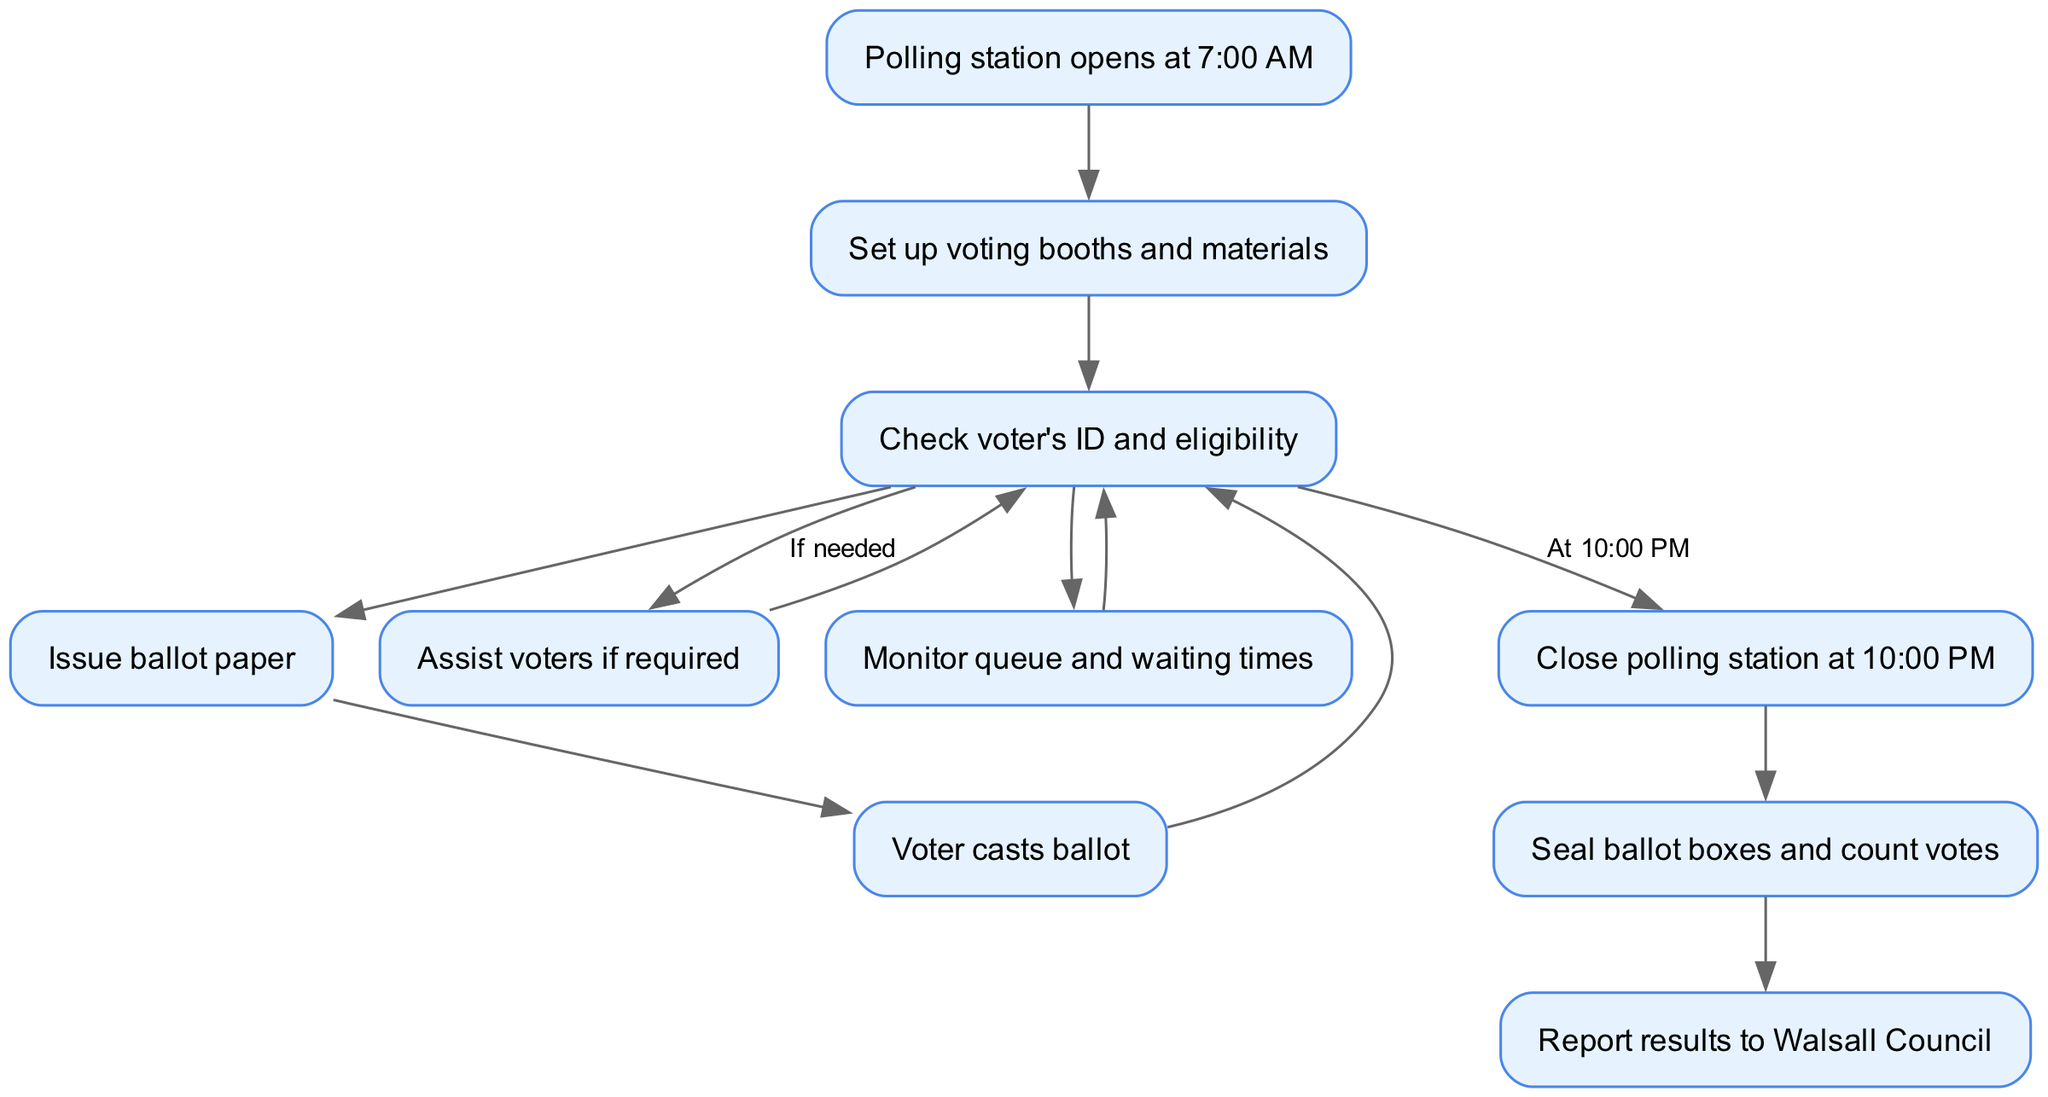What time does the polling station open? The diagram indicates that the polling station opens at 7:00 AM at the starting node.
Answer: 7:00 AM What is the last activity before closing the polling station? The last activity before closing the polling station is to seal ballot boxes and count votes, as shown in the flow following the close node.
Answer: Seal ballot boxes and count votes How many main procedural steps are there before closing the polling station? To answer this, we follow the connections from the setup node through to the check, assist, monitor, and closing, which sums up to six main procedural steps before closing.
Answer: Six What happens to the voter after casting a ballot? The diagram shows that after a voter casts a ballot, they return to the check node, indicating that further steps may occur based on the election procedure.
Answer: Return to check What assistance is provided to voters? If needed, assistance can be provided to voters, as indicated by the connection from the check node to the assist node labeled "If needed."
Answer: Assist voters if required What is issued to voters after checking their ID? After checking a voter's ID and eligibility, the next step is to issue a ballot paper, as shown by the connection from the check node to the issue node.
Answer: Issue ballot paper How do polling station staff monitor the voting process? Staff monitor the voting process by monitoring the queue and waiting times, as indicated by the flow from the check node to the monitor node.
Answer: Monitor queue and waiting times What is reported at the end of the election day procedures? At the end of the election day procedures, results are reported to Walsall Council, as shown in the final step after counting the votes.
Answer: Report results to Walsall Council 